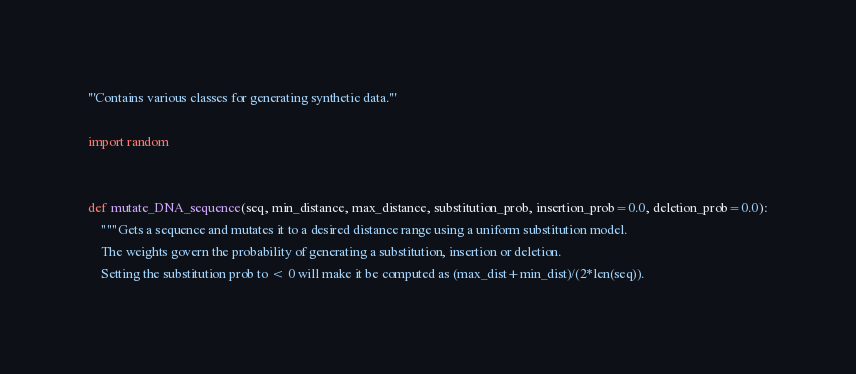Convert code to text. <code><loc_0><loc_0><loc_500><loc_500><_Python_>'''Contains various classes for generating synthetic data.'''

import random


def mutate_DNA_sequence(seq, min_distance, max_distance, substitution_prob, insertion_prob=0.0, deletion_prob=0.0):
    """Gets a sequence and mutates it to a desired distance range using a uniform substitution model.
    The weights govern the probability of generating a substitution, insertion or deletion.
    Setting the substitution prob to < 0 will make it be computed as (max_dist+min_dist)/(2*len(seq)).</code> 